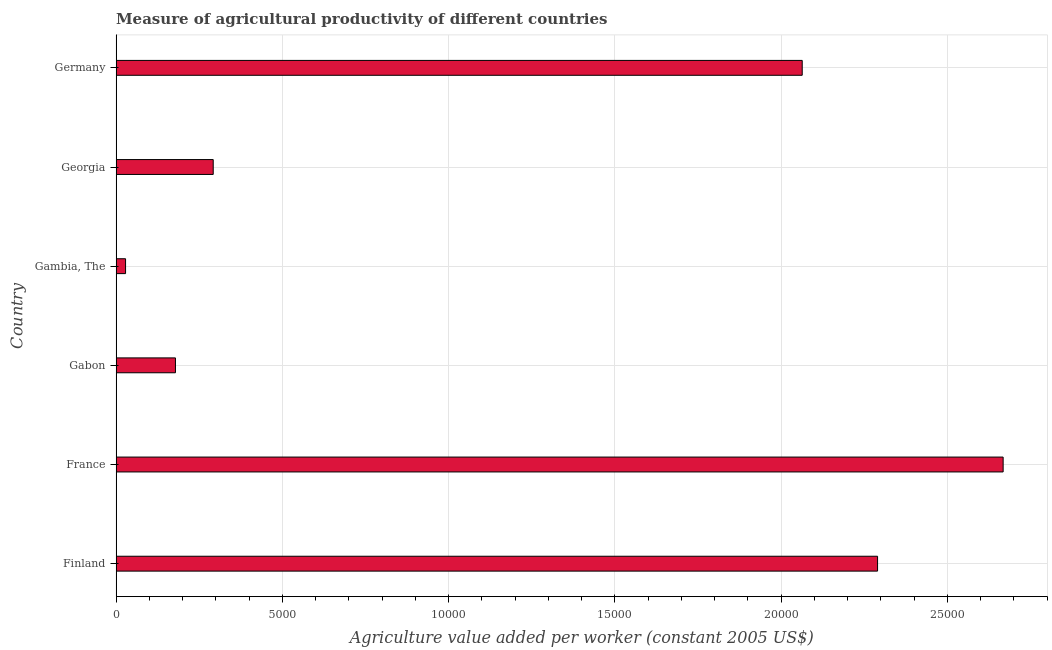Does the graph contain any zero values?
Your answer should be very brief. No. Does the graph contain grids?
Ensure brevity in your answer.  Yes. What is the title of the graph?
Ensure brevity in your answer.  Measure of agricultural productivity of different countries. What is the label or title of the X-axis?
Ensure brevity in your answer.  Agriculture value added per worker (constant 2005 US$). What is the label or title of the Y-axis?
Ensure brevity in your answer.  Country. What is the agriculture value added per worker in Germany?
Offer a very short reply. 2.06e+04. Across all countries, what is the maximum agriculture value added per worker?
Keep it short and to the point. 2.67e+04. Across all countries, what is the minimum agriculture value added per worker?
Your answer should be compact. 283.56. In which country was the agriculture value added per worker minimum?
Give a very brief answer. Gambia, The. What is the sum of the agriculture value added per worker?
Give a very brief answer. 7.52e+04. What is the difference between the agriculture value added per worker in Finland and Gambia, The?
Provide a succinct answer. 2.26e+04. What is the average agriculture value added per worker per country?
Ensure brevity in your answer.  1.25e+04. What is the median agriculture value added per worker?
Your response must be concise. 1.18e+04. In how many countries, is the agriculture value added per worker greater than 22000 US$?
Provide a succinct answer. 2. What is the ratio of the agriculture value added per worker in France to that in Georgia?
Your answer should be very brief. 9.14. Is the agriculture value added per worker in Gambia, The less than that in Georgia?
Keep it short and to the point. Yes. What is the difference between the highest and the second highest agriculture value added per worker?
Make the answer very short. 3776.86. What is the difference between the highest and the lowest agriculture value added per worker?
Offer a terse response. 2.64e+04. How many bars are there?
Your answer should be compact. 6. Are all the bars in the graph horizontal?
Your answer should be compact. Yes. How many countries are there in the graph?
Your answer should be very brief. 6. What is the difference between two consecutive major ticks on the X-axis?
Your answer should be very brief. 5000. Are the values on the major ticks of X-axis written in scientific E-notation?
Your response must be concise. No. What is the Agriculture value added per worker (constant 2005 US$) in Finland?
Provide a short and direct response. 2.29e+04. What is the Agriculture value added per worker (constant 2005 US$) of France?
Make the answer very short. 2.67e+04. What is the Agriculture value added per worker (constant 2005 US$) of Gabon?
Your answer should be very brief. 1784.08. What is the Agriculture value added per worker (constant 2005 US$) in Gambia, The?
Provide a short and direct response. 283.56. What is the Agriculture value added per worker (constant 2005 US$) of Georgia?
Ensure brevity in your answer.  2919.69. What is the Agriculture value added per worker (constant 2005 US$) in Germany?
Make the answer very short. 2.06e+04. What is the difference between the Agriculture value added per worker (constant 2005 US$) in Finland and France?
Provide a short and direct response. -3776.86. What is the difference between the Agriculture value added per worker (constant 2005 US$) in Finland and Gabon?
Your answer should be compact. 2.11e+04. What is the difference between the Agriculture value added per worker (constant 2005 US$) in Finland and Gambia, The?
Your answer should be compact. 2.26e+04. What is the difference between the Agriculture value added per worker (constant 2005 US$) in Finland and Georgia?
Make the answer very short. 2.00e+04. What is the difference between the Agriculture value added per worker (constant 2005 US$) in Finland and Germany?
Make the answer very short. 2265.66. What is the difference between the Agriculture value added per worker (constant 2005 US$) in France and Gabon?
Make the answer very short. 2.49e+04. What is the difference between the Agriculture value added per worker (constant 2005 US$) in France and Gambia, The?
Your answer should be compact. 2.64e+04. What is the difference between the Agriculture value added per worker (constant 2005 US$) in France and Georgia?
Your response must be concise. 2.38e+04. What is the difference between the Agriculture value added per worker (constant 2005 US$) in France and Germany?
Your answer should be compact. 6042.52. What is the difference between the Agriculture value added per worker (constant 2005 US$) in Gabon and Gambia, The?
Give a very brief answer. 1500.52. What is the difference between the Agriculture value added per worker (constant 2005 US$) in Gabon and Georgia?
Your answer should be compact. -1135.61. What is the difference between the Agriculture value added per worker (constant 2005 US$) in Gabon and Germany?
Give a very brief answer. -1.88e+04. What is the difference between the Agriculture value added per worker (constant 2005 US$) in Gambia, The and Georgia?
Your answer should be compact. -2636.13. What is the difference between the Agriculture value added per worker (constant 2005 US$) in Gambia, The and Germany?
Make the answer very short. -2.04e+04. What is the difference between the Agriculture value added per worker (constant 2005 US$) in Georgia and Germany?
Ensure brevity in your answer.  -1.77e+04. What is the ratio of the Agriculture value added per worker (constant 2005 US$) in Finland to that in France?
Offer a very short reply. 0.86. What is the ratio of the Agriculture value added per worker (constant 2005 US$) in Finland to that in Gabon?
Offer a terse response. 12.84. What is the ratio of the Agriculture value added per worker (constant 2005 US$) in Finland to that in Gambia, The?
Keep it short and to the point. 80.76. What is the ratio of the Agriculture value added per worker (constant 2005 US$) in Finland to that in Georgia?
Provide a succinct answer. 7.84. What is the ratio of the Agriculture value added per worker (constant 2005 US$) in Finland to that in Germany?
Ensure brevity in your answer.  1.11. What is the ratio of the Agriculture value added per worker (constant 2005 US$) in France to that in Gabon?
Ensure brevity in your answer.  14.95. What is the ratio of the Agriculture value added per worker (constant 2005 US$) in France to that in Gambia, The?
Your answer should be very brief. 94.08. What is the ratio of the Agriculture value added per worker (constant 2005 US$) in France to that in Georgia?
Give a very brief answer. 9.14. What is the ratio of the Agriculture value added per worker (constant 2005 US$) in France to that in Germany?
Give a very brief answer. 1.29. What is the ratio of the Agriculture value added per worker (constant 2005 US$) in Gabon to that in Gambia, The?
Provide a short and direct response. 6.29. What is the ratio of the Agriculture value added per worker (constant 2005 US$) in Gabon to that in Georgia?
Give a very brief answer. 0.61. What is the ratio of the Agriculture value added per worker (constant 2005 US$) in Gabon to that in Germany?
Your answer should be compact. 0.09. What is the ratio of the Agriculture value added per worker (constant 2005 US$) in Gambia, The to that in Georgia?
Provide a succinct answer. 0.1. What is the ratio of the Agriculture value added per worker (constant 2005 US$) in Gambia, The to that in Germany?
Offer a very short reply. 0.01. What is the ratio of the Agriculture value added per worker (constant 2005 US$) in Georgia to that in Germany?
Give a very brief answer. 0.14. 